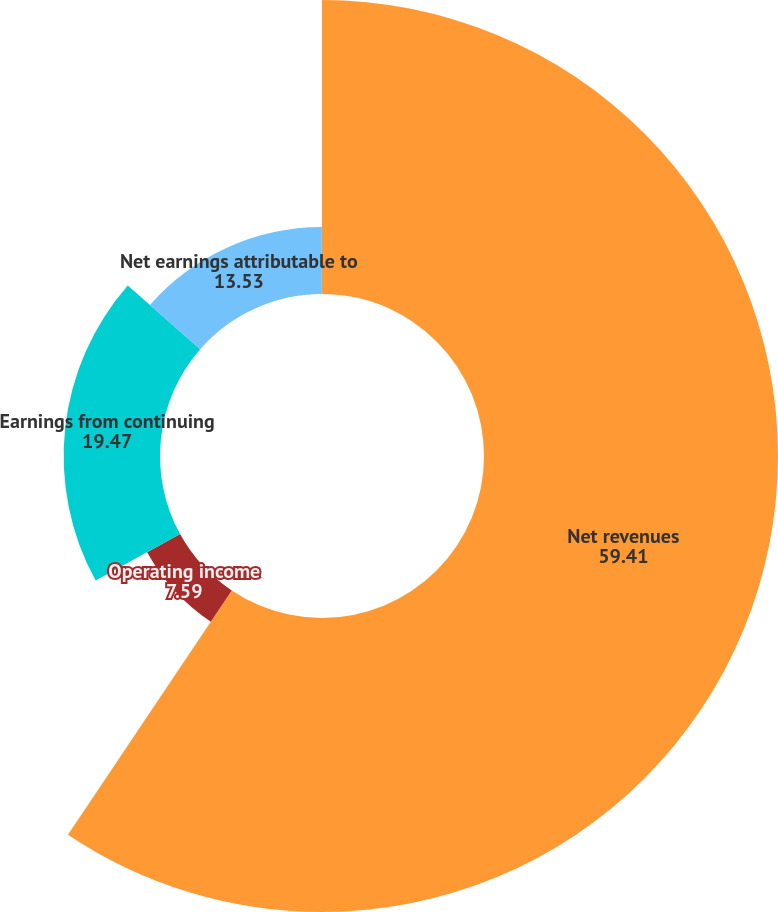Convert chart. <chart><loc_0><loc_0><loc_500><loc_500><pie_chart><fcel>Net revenues<fcel>Operating income<fcel>Earnings from continuing<fcel>Net earnings attributable to<fcel>Diluted earnings per share<nl><fcel>59.41%<fcel>7.59%<fcel>19.47%<fcel>13.53%<fcel>0.01%<nl></chart> 